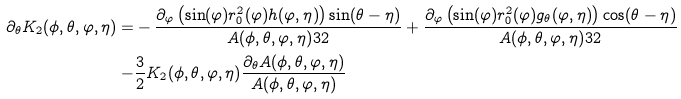<formula> <loc_0><loc_0><loc_500><loc_500>\partial _ { \theta } K _ { 2 } ( \phi , \theta , \varphi , \eta ) = & - \frac { \partial _ { \varphi } \left ( \sin ( \varphi ) r _ { 0 } ^ { 2 } ( \varphi ) h ( \varphi , \eta ) \right ) \sin ( \theta - \eta ) } { A ( \phi , \theta , \varphi , \eta ) ^ { } { 3 } 2 } + \frac { \partial _ { \varphi } \left ( \sin ( \varphi ) r _ { 0 } ^ { 2 } ( \varphi ) g _ { \theta } ( \varphi , \eta ) \right ) \cos ( \theta - \eta ) } { A ( \phi , \theta , \varphi , \eta ) ^ { } { 3 } 2 } \\ - & \frac { 3 } { 2 } K _ { 2 } ( \phi , \theta , \varphi , \eta ) \frac { \partial _ { \theta } A ( \phi , \theta , \varphi , \eta ) } { A ( \phi , \theta , \varphi , \eta ) }</formula> 